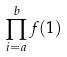Convert formula to latex. <formula><loc_0><loc_0><loc_500><loc_500>\prod _ { i = a } ^ { b } f ( 1 )</formula> 